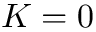Convert formula to latex. <formula><loc_0><loc_0><loc_500><loc_500>K = 0</formula> 